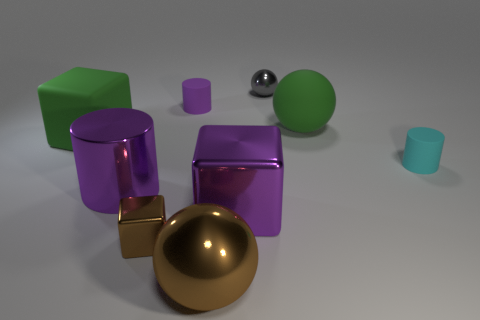Can you describe the shapes of the objects in the image? Certainly! The image features a variety of geometric shapes: there are cubes, a sphere, a cylinder, and what appears to be a torus. These shapes give the image a sense of balance and diversity in form. 